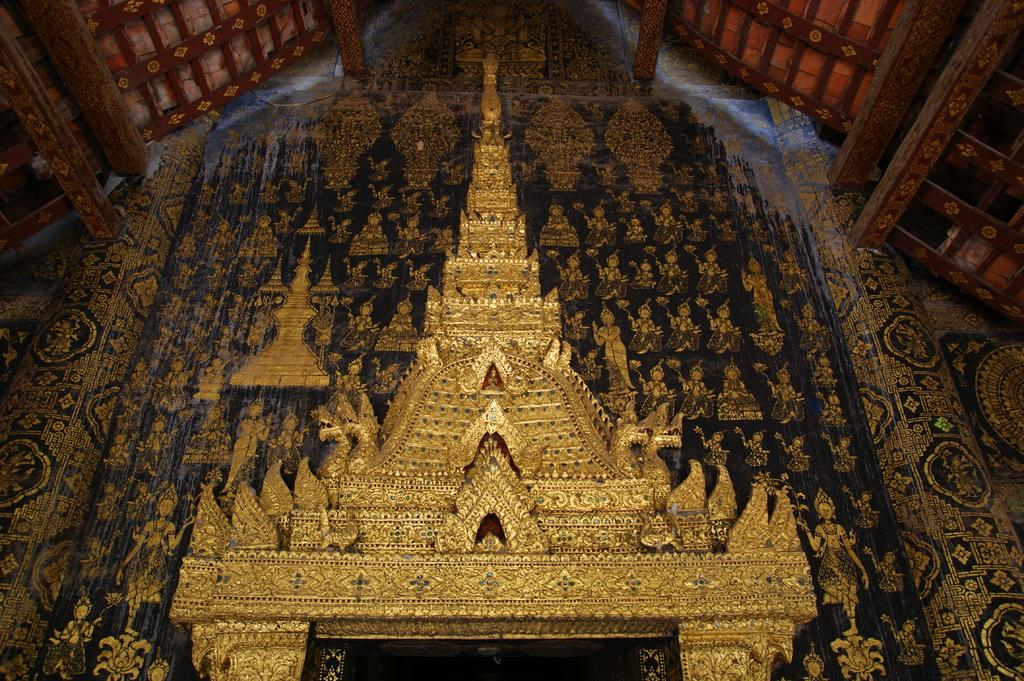What type of building is in the picture? There is a Chinese temple in the picture. What material is the temple constructed with? The temple is constructed with gold. What other structure can be seen in the picture? There is a shed in the picture. What can be found on the wall under the shed? There are designs on the wall under the shed. How does the jelly feel when it touches the twig in the image? There is no jelly or twig present in the image. 